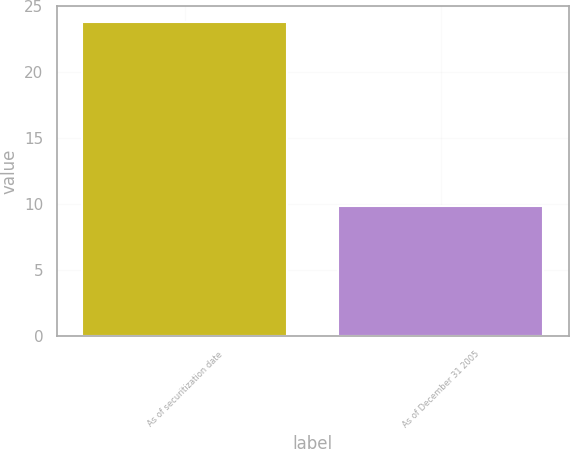Convert chart. <chart><loc_0><loc_0><loc_500><loc_500><bar_chart><fcel>As of securitization date<fcel>As of December 31 2005<nl><fcel>23.81<fcel>9.85<nl></chart> 